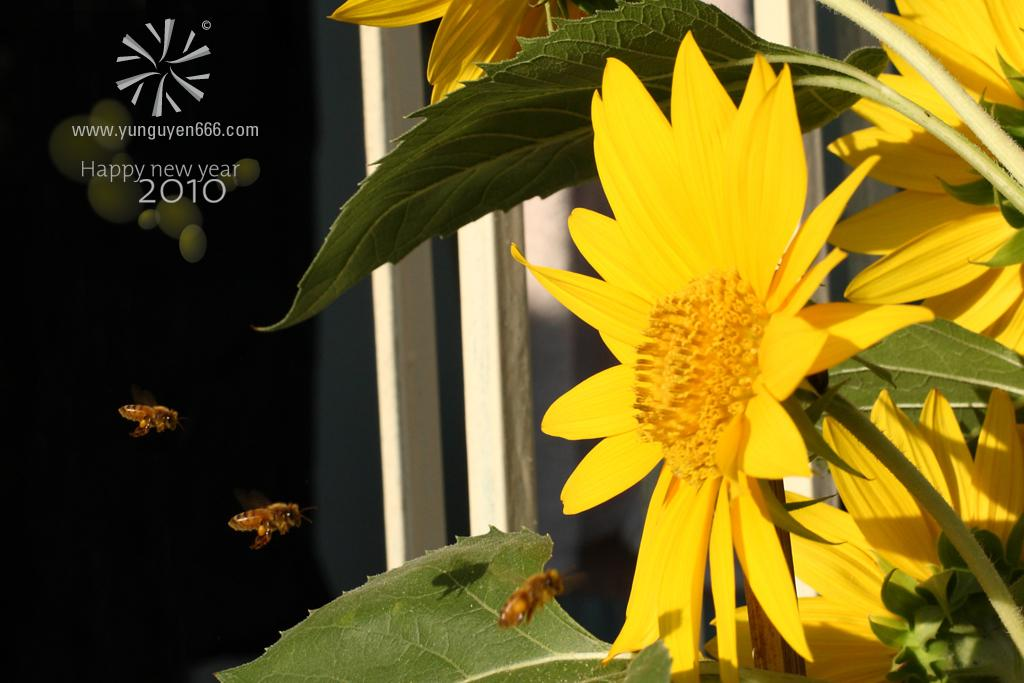What is located in the foreground of the image? There are flowers and bees in the foreground of the image. What type of plant can be seen in the image? It appears there are bamboos in the image. What is visible in the background of the image? There is text visible in the background of the image. What emotion is the goat expressing in the image? There is no goat present in the image, so it is not possible to determine the emotion it might be expressing. 